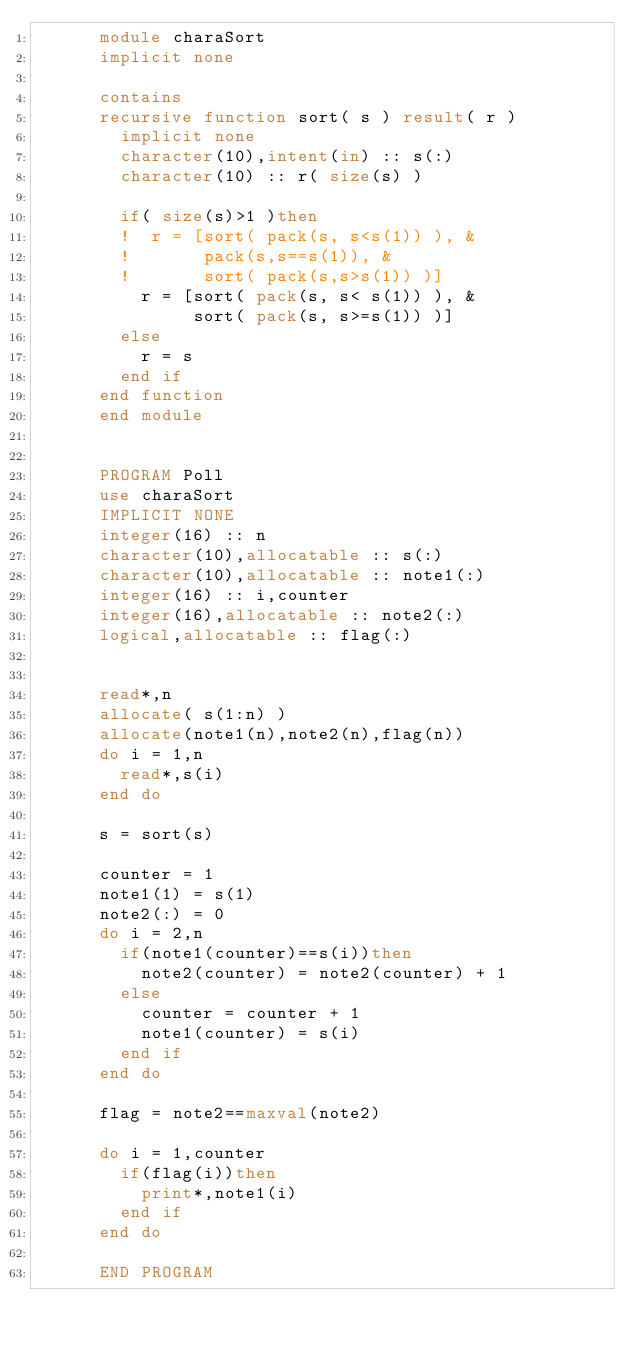Convert code to text. <code><loc_0><loc_0><loc_500><loc_500><_FORTRAN_>      module charaSort
      implicit none
      
      contains
      recursive function sort( s ) result( r )
        implicit none
        character(10),intent(in) :: s(:)
        character(10) :: r( size(s) )
        
        if( size(s)>1 )then
        !  r = [sort( pack(s, s<s(1)) ), &
        !       pack(s,s==s(1)), &
        !       sort( pack(s,s>s(1)) )]
          r = [sort( pack(s, s< s(1)) ), &
               sort( pack(s, s>=s(1)) )]
        else
          r = s
        end if
      end function
      end module


      PROGRAM Poll
      use charaSort
      IMPLICIT NONE
      integer(16) :: n
      character(10),allocatable :: s(:)
      character(10),allocatable :: note1(:)
      integer(16) :: i,counter
      integer(16),allocatable :: note2(:)
      logical,allocatable :: flag(:)
      
      
      read*,n
      allocate( s(1:n) )
      allocate(note1(n),note2(n),flag(n))
      do i = 1,n
        read*,s(i)
      end do
      
      s = sort(s)
      
      counter = 1
      note1(1) = s(1)
      note2(:) = 0
      do i = 2,n
        if(note1(counter)==s(i))then
          note2(counter) = note2(counter) + 1
        else
          counter = counter + 1
          note1(counter) = s(i)
        end if
      end do
      
      flag = note2==maxval(note2)
      
      do i = 1,counter
        if(flag(i))then
          print*,note1(i)
        end if
      end do
      
      END PROGRAM</code> 